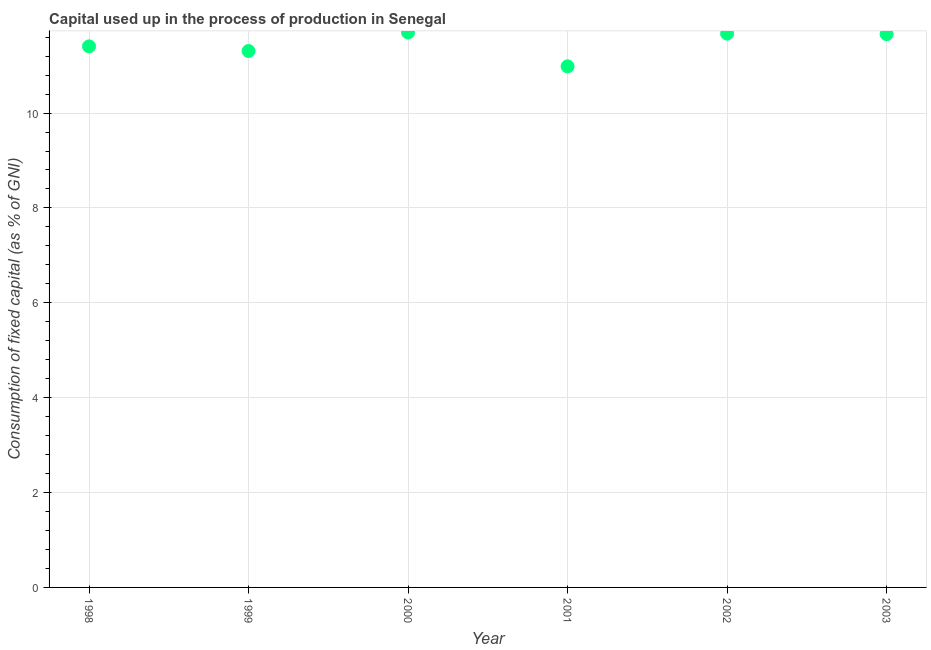What is the consumption of fixed capital in 2002?
Make the answer very short. 11.67. Across all years, what is the maximum consumption of fixed capital?
Provide a succinct answer. 11.7. Across all years, what is the minimum consumption of fixed capital?
Provide a succinct answer. 10.99. In which year was the consumption of fixed capital maximum?
Offer a terse response. 2000. In which year was the consumption of fixed capital minimum?
Ensure brevity in your answer.  2001. What is the sum of the consumption of fixed capital?
Keep it short and to the point. 68.74. What is the difference between the consumption of fixed capital in 1998 and 2001?
Your answer should be very brief. 0.42. What is the average consumption of fixed capital per year?
Offer a very short reply. 11.46. What is the median consumption of fixed capital?
Offer a very short reply. 11.53. Do a majority of the years between 2000 and 1999 (inclusive) have consumption of fixed capital greater than 9.6 %?
Provide a succinct answer. No. What is the ratio of the consumption of fixed capital in 1998 to that in 2002?
Keep it short and to the point. 0.98. Is the consumption of fixed capital in 2001 less than that in 2003?
Your response must be concise. Yes. What is the difference between the highest and the second highest consumption of fixed capital?
Provide a succinct answer. 0.02. What is the difference between the highest and the lowest consumption of fixed capital?
Your answer should be very brief. 0.71. Does the consumption of fixed capital monotonically increase over the years?
Provide a succinct answer. No. Are the values on the major ticks of Y-axis written in scientific E-notation?
Offer a terse response. No. Does the graph contain grids?
Your response must be concise. Yes. What is the title of the graph?
Give a very brief answer. Capital used up in the process of production in Senegal. What is the label or title of the Y-axis?
Provide a succinct answer. Consumption of fixed capital (as % of GNI). What is the Consumption of fixed capital (as % of GNI) in 1998?
Provide a short and direct response. 11.41. What is the Consumption of fixed capital (as % of GNI) in 1999?
Offer a terse response. 11.31. What is the Consumption of fixed capital (as % of GNI) in 2000?
Your answer should be compact. 11.7. What is the Consumption of fixed capital (as % of GNI) in 2001?
Offer a very short reply. 10.99. What is the Consumption of fixed capital (as % of GNI) in 2002?
Provide a succinct answer. 11.67. What is the Consumption of fixed capital (as % of GNI) in 2003?
Keep it short and to the point. 11.66. What is the difference between the Consumption of fixed capital (as % of GNI) in 1998 and 1999?
Your answer should be very brief. 0.1. What is the difference between the Consumption of fixed capital (as % of GNI) in 1998 and 2000?
Keep it short and to the point. -0.29. What is the difference between the Consumption of fixed capital (as % of GNI) in 1998 and 2001?
Keep it short and to the point. 0.42. What is the difference between the Consumption of fixed capital (as % of GNI) in 1998 and 2002?
Make the answer very short. -0.27. What is the difference between the Consumption of fixed capital (as % of GNI) in 1998 and 2003?
Your answer should be very brief. -0.26. What is the difference between the Consumption of fixed capital (as % of GNI) in 1999 and 2000?
Ensure brevity in your answer.  -0.39. What is the difference between the Consumption of fixed capital (as % of GNI) in 1999 and 2001?
Ensure brevity in your answer.  0.32. What is the difference between the Consumption of fixed capital (as % of GNI) in 1999 and 2002?
Keep it short and to the point. -0.37. What is the difference between the Consumption of fixed capital (as % of GNI) in 1999 and 2003?
Your answer should be compact. -0.36. What is the difference between the Consumption of fixed capital (as % of GNI) in 2000 and 2001?
Make the answer very short. 0.71. What is the difference between the Consumption of fixed capital (as % of GNI) in 2000 and 2002?
Give a very brief answer. 0.02. What is the difference between the Consumption of fixed capital (as % of GNI) in 2000 and 2003?
Provide a short and direct response. 0.03. What is the difference between the Consumption of fixed capital (as % of GNI) in 2001 and 2002?
Keep it short and to the point. -0.69. What is the difference between the Consumption of fixed capital (as % of GNI) in 2001 and 2003?
Offer a very short reply. -0.68. What is the difference between the Consumption of fixed capital (as % of GNI) in 2002 and 2003?
Your response must be concise. 0.01. What is the ratio of the Consumption of fixed capital (as % of GNI) in 1998 to that in 2001?
Offer a very short reply. 1.04. What is the ratio of the Consumption of fixed capital (as % of GNI) in 1998 to that in 2003?
Make the answer very short. 0.98. What is the ratio of the Consumption of fixed capital (as % of GNI) in 1999 to that in 2000?
Provide a short and direct response. 0.97. What is the ratio of the Consumption of fixed capital (as % of GNI) in 1999 to that in 2001?
Ensure brevity in your answer.  1.03. What is the ratio of the Consumption of fixed capital (as % of GNI) in 1999 to that in 2002?
Your answer should be compact. 0.97. What is the ratio of the Consumption of fixed capital (as % of GNI) in 1999 to that in 2003?
Provide a short and direct response. 0.97. What is the ratio of the Consumption of fixed capital (as % of GNI) in 2000 to that in 2001?
Your answer should be compact. 1.06. What is the ratio of the Consumption of fixed capital (as % of GNI) in 2000 to that in 2002?
Provide a succinct answer. 1. What is the ratio of the Consumption of fixed capital (as % of GNI) in 2000 to that in 2003?
Make the answer very short. 1. What is the ratio of the Consumption of fixed capital (as % of GNI) in 2001 to that in 2002?
Your response must be concise. 0.94. What is the ratio of the Consumption of fixed capital (as % of GNI) in 2001 to that in 2003?
Offer a terse response. 0.94. What is the ratio of the Consumption of fixed capital (as % of GNI) in 2002 to that in 2003?
Keep it short and to the point. 1. 